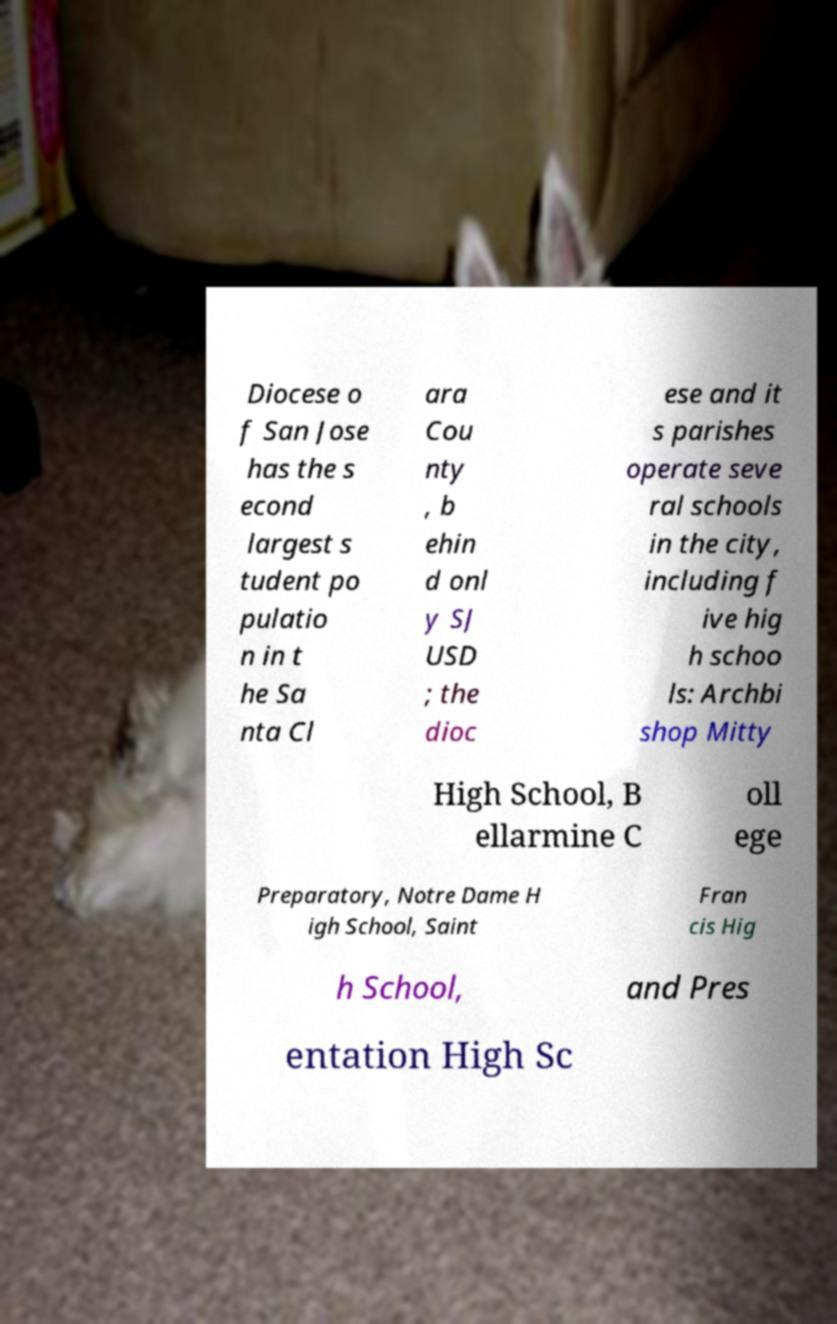What messages or text are displayed in this image? I need them in a readable, typed format. Diocese o f San Jose has the s econd largest s tudent po pulatio n in t he Sa nta Cl ara Cou nty , b ehin d onl y SJ USD ; the dioc ese and it s parishes operate seve ral schools in the city, including f ive hig h schoo ls: Archbi shop Mitty High School, B ellarmine C oll ege Preparatory, Notre Dame H igh School, Saint Fran cis Hig h School, and Pres entation High Sc 